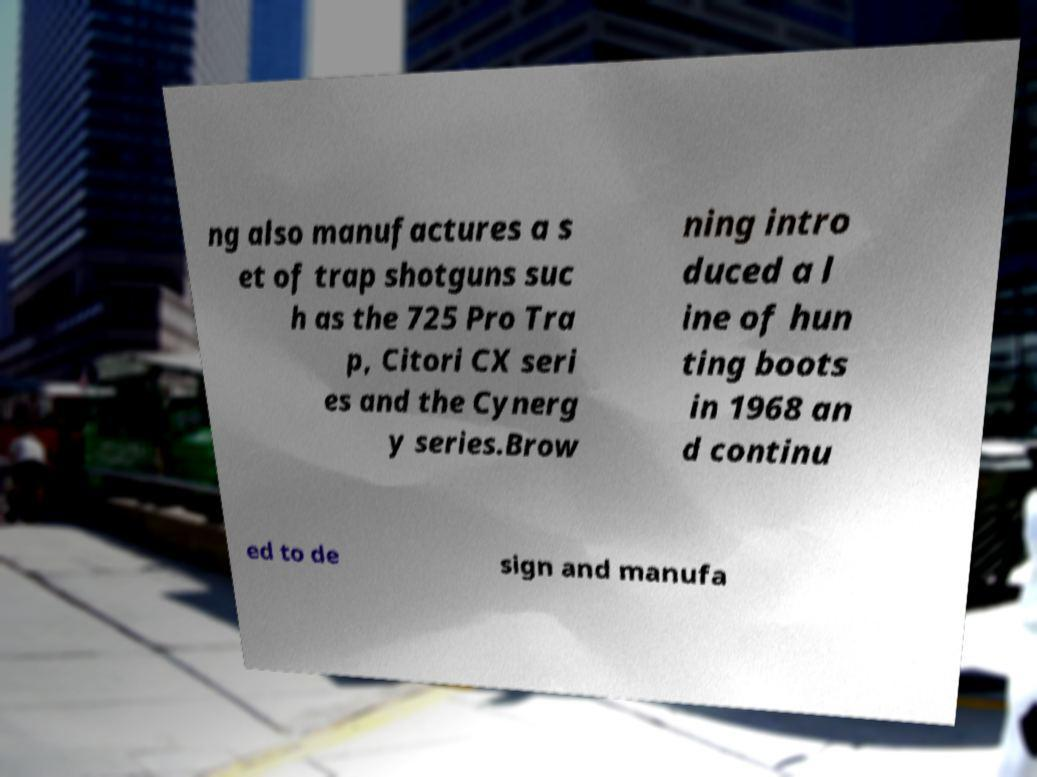What messages or text are displayed in this image? I need them in a readable, typed format. ng also manufactures a s et of trap shotguns suc h as the 725 Pro Tra p, Citori CX seri es and the Cynerg y series.Brow ning intro duced a l ine of hun ting boots in 1968 an d continu ed to de sign and manufa 